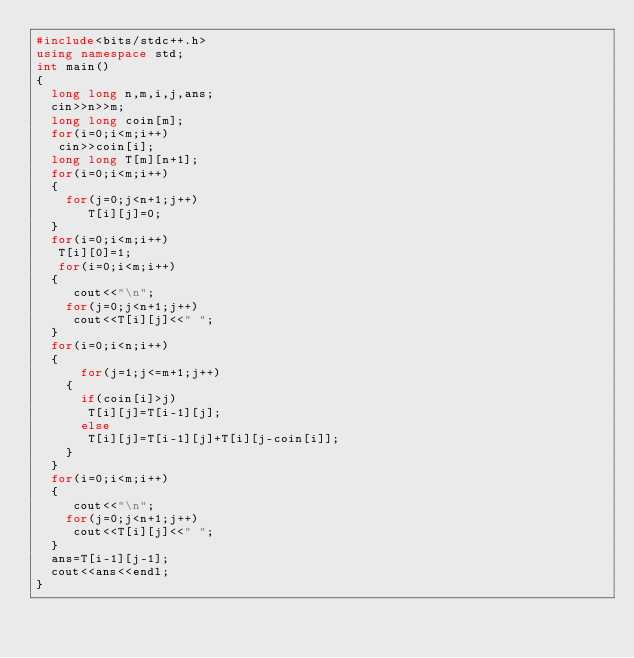Convert code to text. <code><loc_0><loc_0><loc_500><loc_500><_C++_>#include<bits/stdc++.h>
using namespace std;
int main()
{
	long long n,m,i,j,ans;
	cin>>n>>m;
	long long coin[m];
	for(i=0;i<m;i++)
	 cin>>coin[i];
	long long T[m][n+1];
	for(i=0;i<m;i++)
	{   
		for(j=0;j<n+1;j++)
		   T[i][j]=0;
	}
	for(i=0;i<m;i++)
	 T[i][0]=1;
	 for(i=0;i<m;i++)
	{   
	   cout<<"\n";
		for(j=0;j<n+1;j++)
		 cout<<T[i][j]<<" ";
	}
	for(i=0;i<n;i++)
	{
	   	for(j=1;j<=m+1;j++)
		{
			if(coin[i]>j)
			 T[i][j]=T[i-1][j];
			else
			 T[i][j]=T[i-1][j]+T[i][j-coin[i]];
		}
	}
	for(i=0;i<m;i++)
	{   
	   cout<<"\n";
		for(j=0;j<n+1;j++)
		 cout<<T[i][j]<<" ";
	}
	ans=T[i-1][j-1];
	cout<<ans<<endl;
}
</code> 